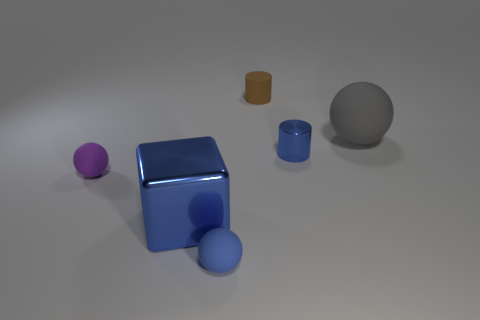Add 1 red shiny cylinders. How many objects exist? 7 Subtract all cylinders. How many objects are left? 4 Add 1 matte balls. How many matte balls are left? 4 Add 6 large gray shiny cylinders. How many large gray shiny cylinders exist? 6 Subtract 1 blue cylinders. How many objects are left? 5 Subtract all small brown blocks. Subtract all tiny metallic cylinders. How many objects are left? 5 